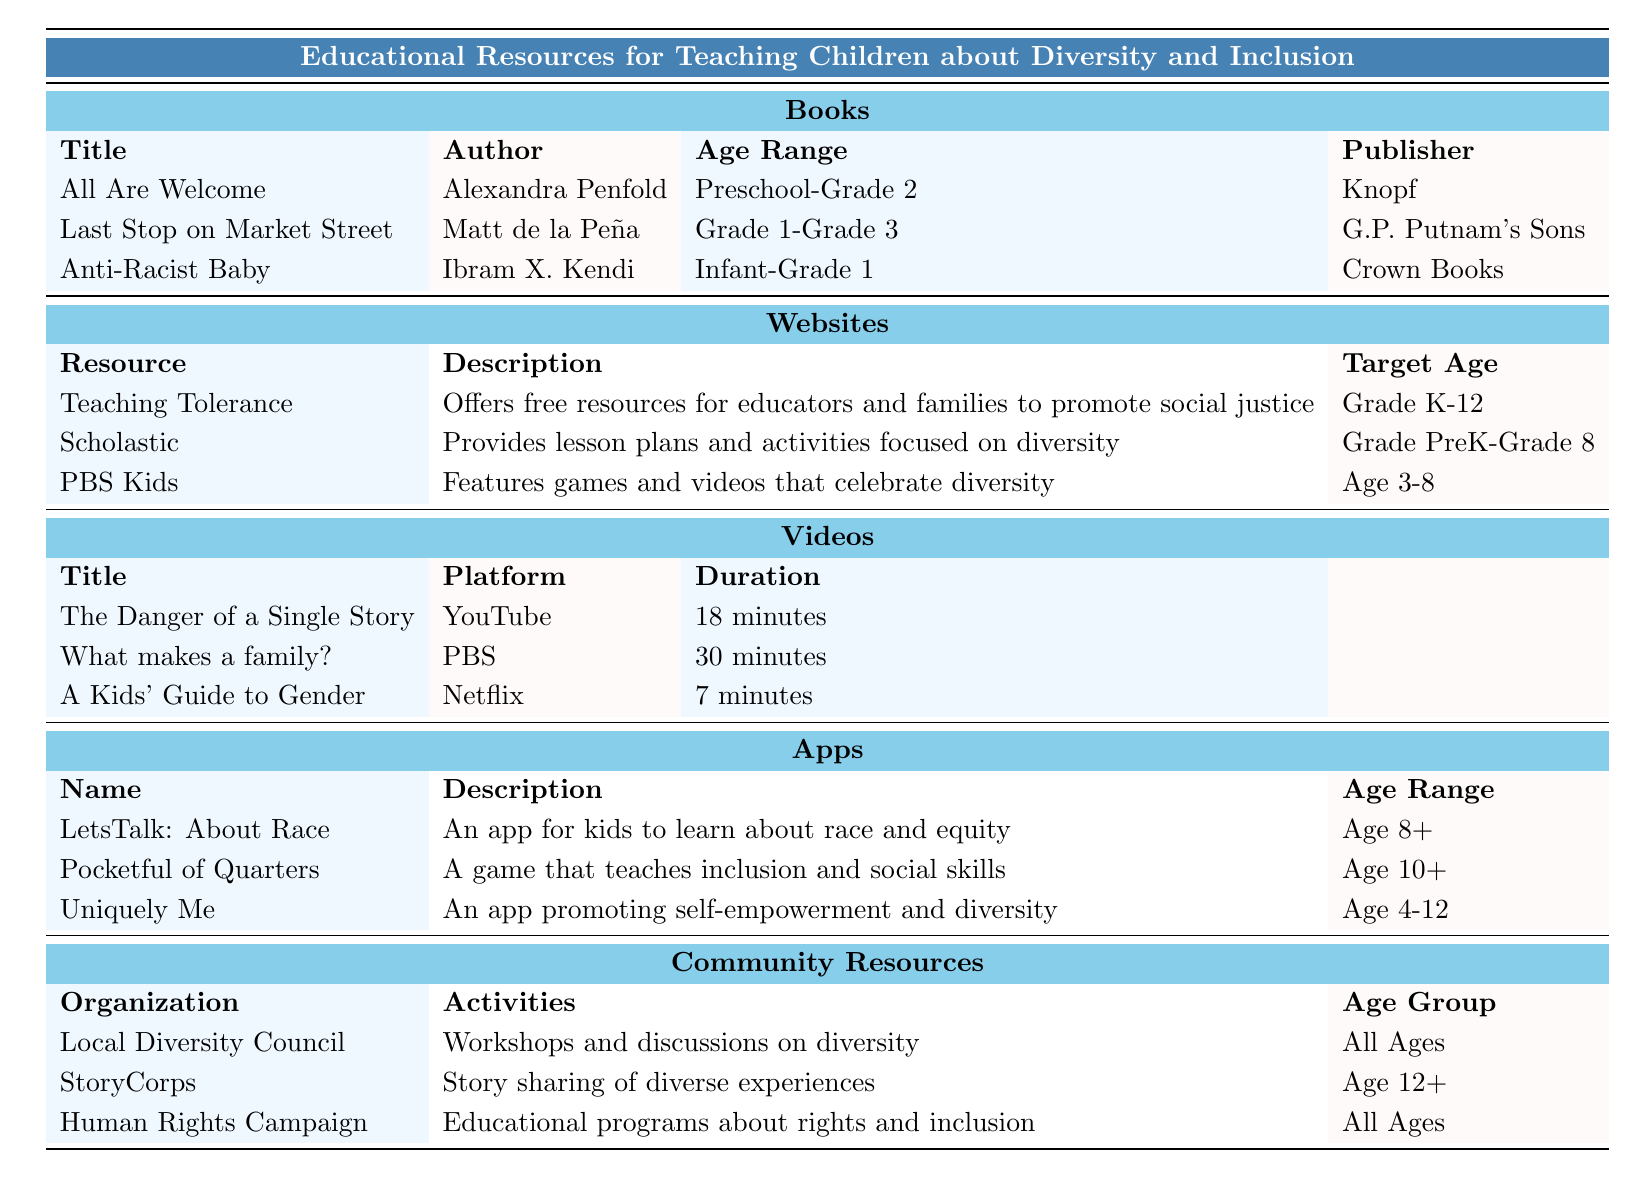What is the age range for the book "Anti-Racist Baby"? The table clearly lists "Infant-Grade 1" as the age range under the "Books" section for the title "Anti-Racist Baby."
Answer: Infant-Grade 1 Which website offers resources for all grades K-12? The table shows that "Teaching Tolerance" provides resources that target "Grade K-12."
Answer: Teaching Tolerance What is the duration of the video "What makes a family?" The table states that "What makes a family?" has a duration of "30 minutes."
Answer: 30 minutes How many apps target children aged 10 and older? Referring to the Apps section, only "Pocketful of Quarters" targets children "Age 10+," which is just one app.
Answer: 1 Is "Last Stop on Market Street" authored by Ibram X. Kendi? The table lists "Last Stop on Market Street" under the author "Matt de la Peña," so this statement is false.
Answer: No What types of activities does the Local Diversity Council provide? The table states that the Local Diversity Council offers "Workshops and discussions on diversity," which is an educational activity.
Answer: Workshops and discussions on diversity How many videos are listed in the table? The Videos section includes three titles: "The Danger of a Single Story," "What makes a family?" and "A Kids’ Guide to Gender," making a total of three videos.
Answer: 3 Which app focuses on self-empowerment and diversity? The "Uniquely Me" app is specified in the table as promoting self-empowerment and diversity.
Answer: Uniquely Me What is the common target age for the Community Resources listed? The "Local Diversity Council" and "Human Rights Campaign" resources target "All Ages," while "StoryCorps" targets "Age 12+" suggesting a mix. The common group is "All Ages."
Answer: All Ages Which author has the most books listed in the table? Only one book is provided for each author, with Alexandra Penfold ("All Are Welcome"), Matt de la Peña ("Last Stop on Market Street"), and Ibram X. Kendi ("Anti-Racist Baby"), so no author has more than one book listed.
Answer: None What is the main focus of the "PBS Kids" resource? The table describes "PBS Kids" as featuring games and videos that celebrate diversity, highlighting its focus on entertainment and educational content related to diversity.
Answer: Games and videos that celebrate diversity 